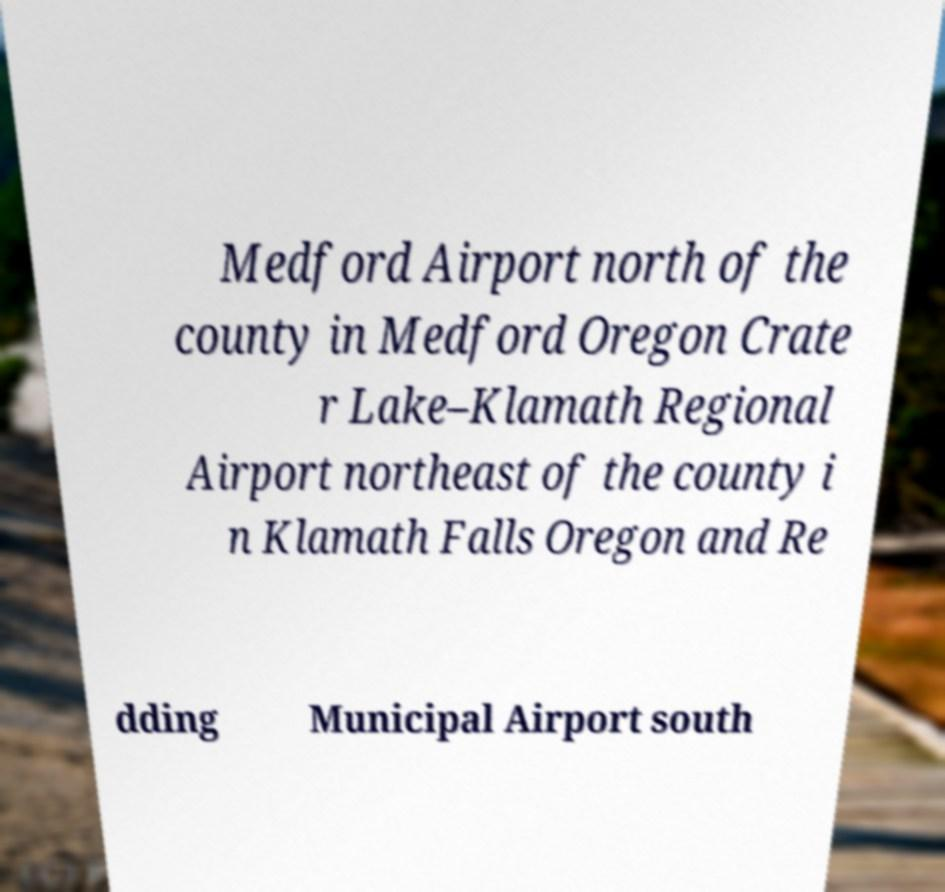Could you assist in decoding the text presented in this image and type it out clearly? Medford Airport north of the county in Medford Oregon Crate r Lake–Klamath Regional Airport northeast of the county i n Klamath Falls Oregon and Re dding Municipal Airport south 